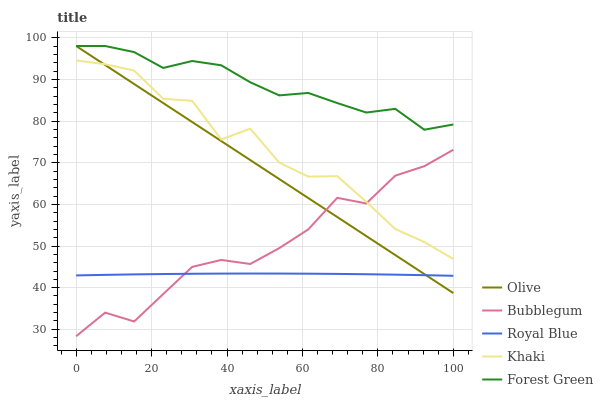Does Royal Blue have the minimum area under the curve?
Answer yes or no. Yes. Does Forest Green have the maximum area under the curve?
Answer yes or no. Yes. Does Forest Green have the minimum area under the curve?
Answer yes or no. No. Does Royal Blue have the maximum area under the curve?
Answer yes or no. No. Is Olive the smoothest?
Answer yes or no. Yes. Is Khaki the roughest?
Answer yes or no. Yes. Is Royal Blue the smoothest?
Answer yes or no. No. Is Royal Blue the roughest?
Answer yes or no. No. Does Bubblegum have the lowest value?
Answer yes or no. Yes. Does Royal Blue have the lowest value?
Answer yes or no. No. Does Forest Green have the highest value?
Answer yes or no. Yes. Does Royal Blue have the highest value?
Answer yes or no. No. Is Royal Blue less than Khaki?
Answer yes or no. Yes. Is Khaki greater than Royal Blue?
Answer yes or no. Yes. Does Olive intersect Forest Green?
Answer yes or no. Yes. Is Olive less than Forest Green?
Answer yes or no. No. Is Olive greater than Forest Green?
Answer yes or no. No. Does Royal Blue intersect Khaki?
Answer yes or no. No. 